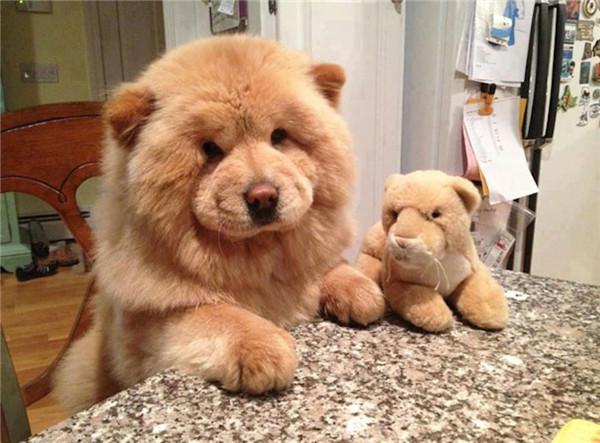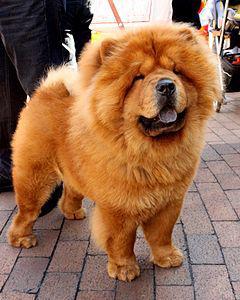The first image is the image on the left, the second image is the image on the right. For the images displayed, is the sentence "A chow dog is shown standing on brick." factually correct? Answer yes or no. Yes. 